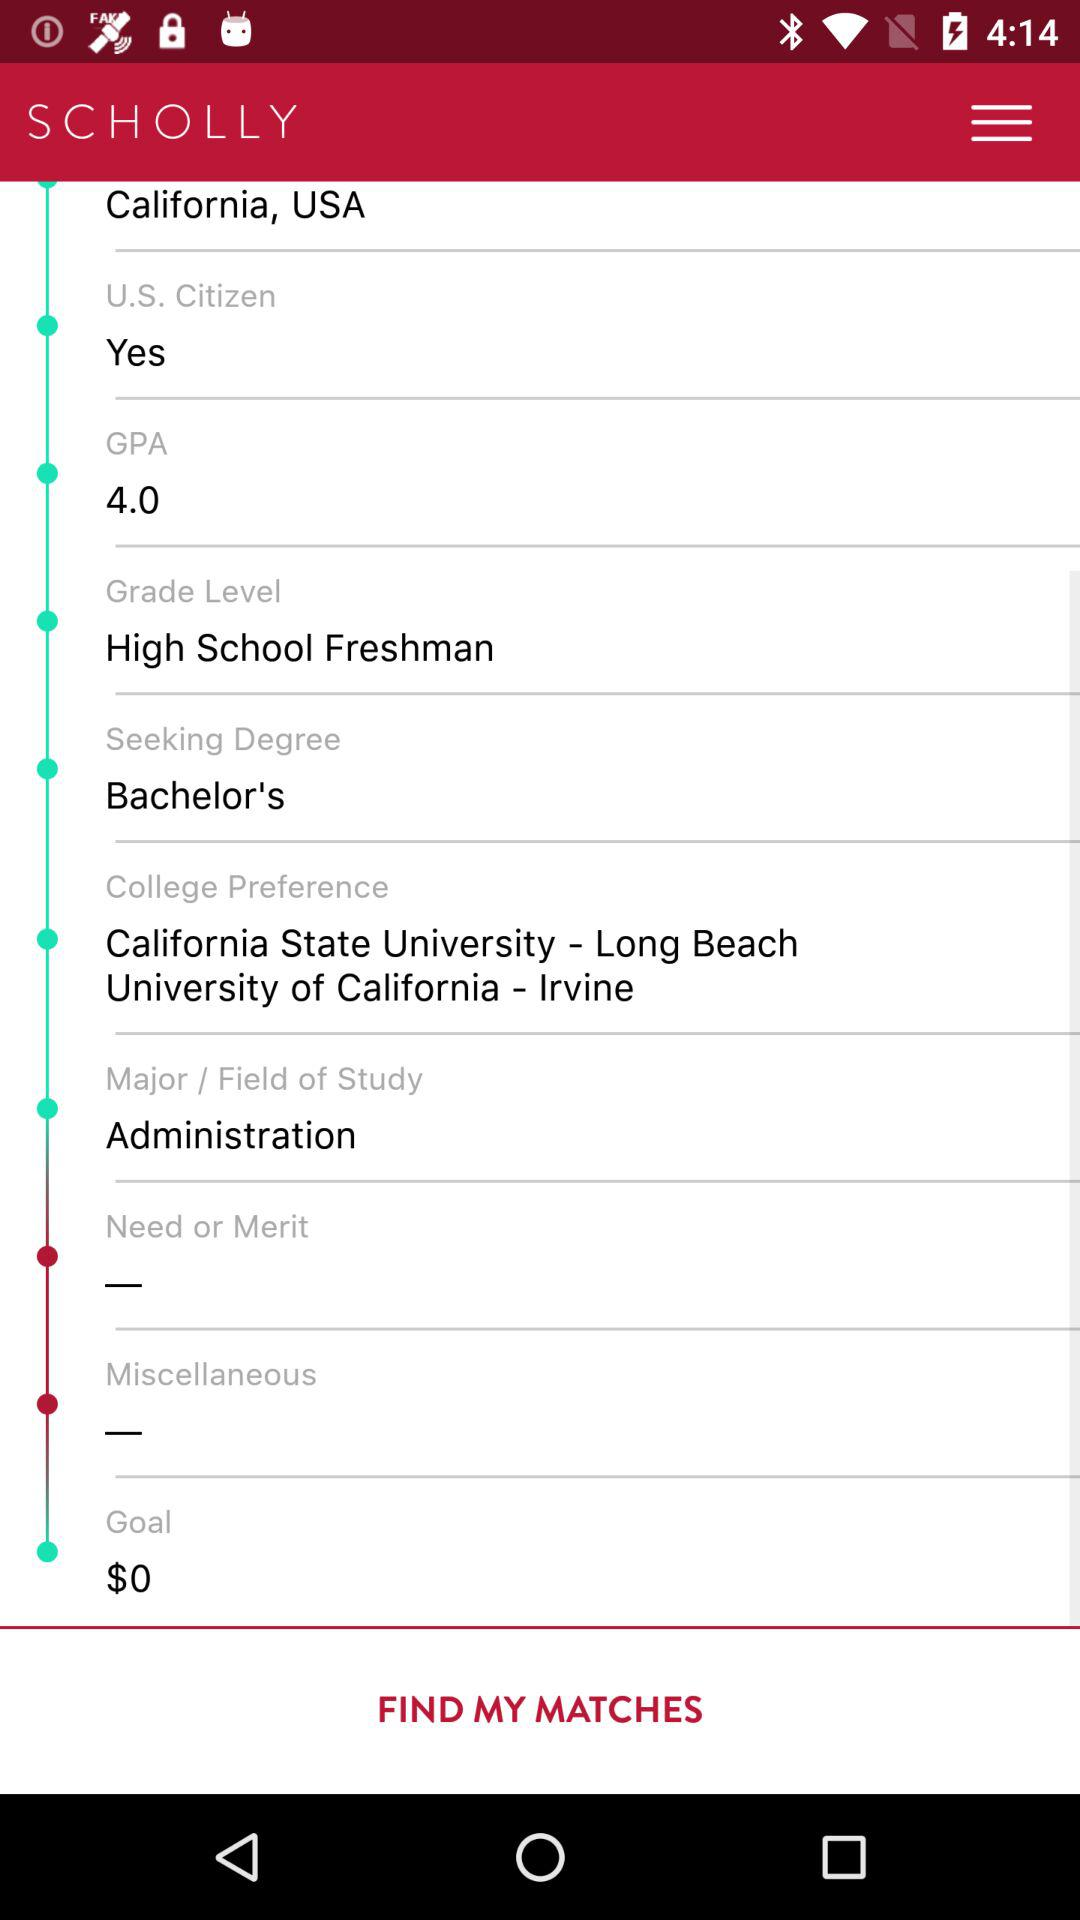What is the goal? The goal is $0. 